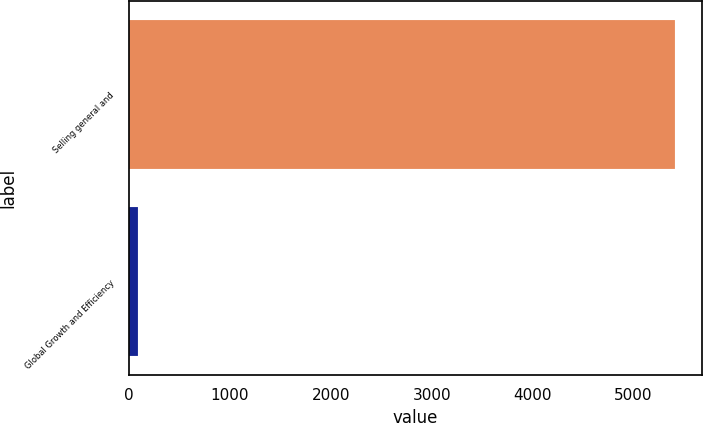Convert chart. <chart><loc_0><loc_0><loc_500><loc_500><bar_chart><fcel>Selling general and<fcel>Global Growth and Efficiency<nl><fcel>5408<fcel>89<nl></chart> 